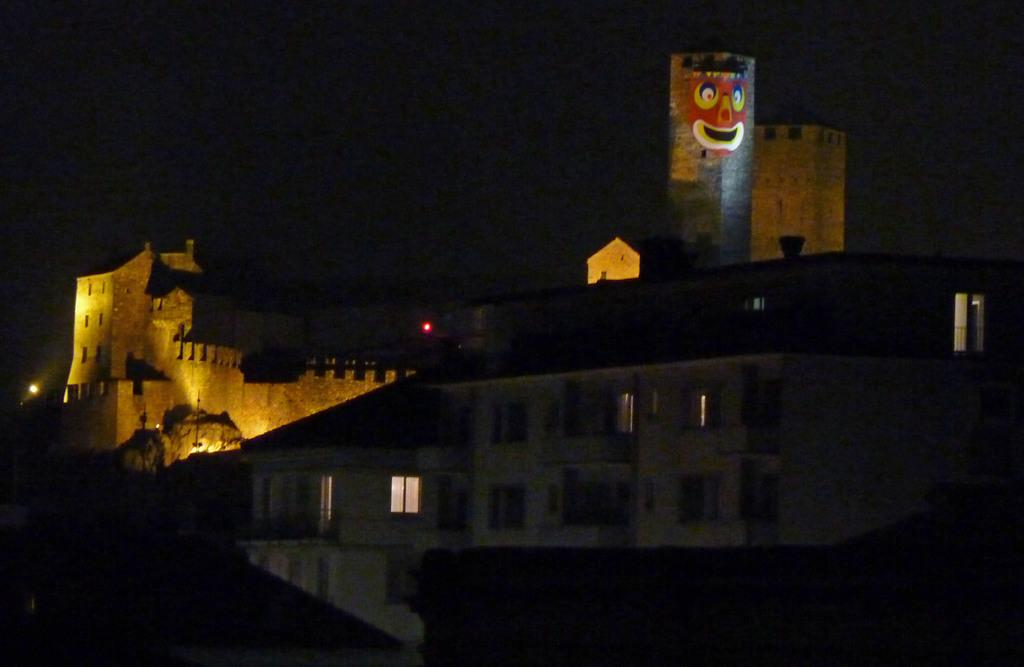What type of structure is present in the image? There is a building and a fort in the image. Can you describe the lighting conditions in the image? There are lights visible in the image. What is the color of the background in the image? The background of the image is dark. What type of book is being read by the thunder in the image? There is no thunder or book present in the image. Can you tell me how many uncles are visible in the image? There are no uncles visible in the image. 